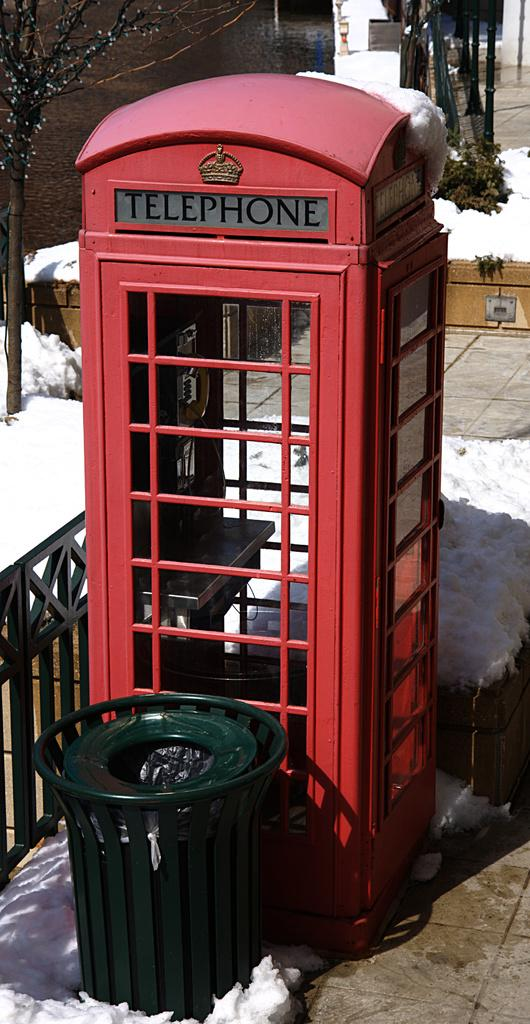<image>
Describe the image concisely. A phone booth is visible with a trash can beside it. 